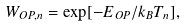Convert formula to latex. <formula><loc_0><loc_0><loc_500><loc_500>W _ { O P , n } = \exp [ - E _ { O P } / k _ { B } T _ { n } ] ,</formula> 